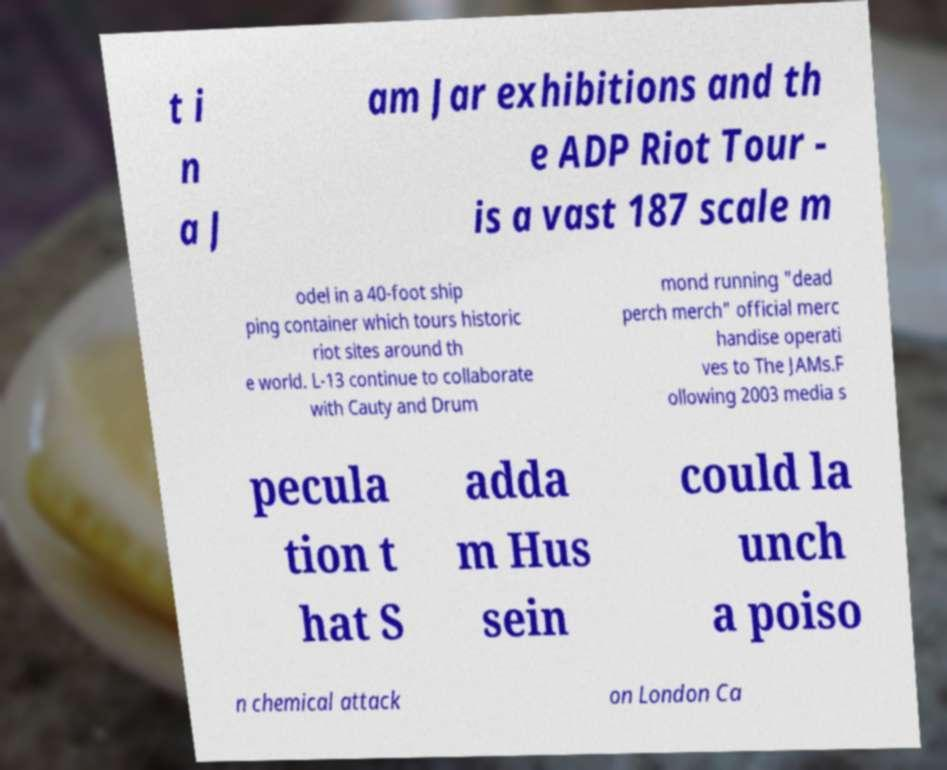I need the written content from this picture converted into text. Can you do that? t i n a J am Jar exhibitions and th e ADP Riot Tour - is a vast 187 scale m odel in a 40-foot ship ping container which tours historic riot sites around th e world. L-13 continue to collaborate with Cauty and Drum mond running "dead perch merch" official merc handise operati ves to The JAMs.F ollowing 2003 media s pecula tion t hat S adda m Hus sein could la unch a poiso n chemical attack on London Ca 